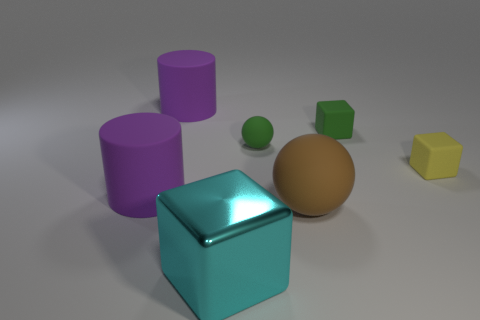There is a cyan metal object that is the same shape as the yellow object; what size is it?
Your answer should be compact. Large. Is the number of spheres that are left of the cyan thing the same as the number of small green balls behind the brown sphere?
Provide a short and direct response. No. What number of other things are the same material as the green block?
Your answer should be compact. 5. Is the number of yellow matte blocks that are left of the green rubber sphere the same as the number of blue matte spheres?
Provide a short and direct response. Yes. Does the brown object have the same size as the matte cube that is on the left side of the yellow cube?
Your response must be concise. No. There is a big rubber thing that is on the right side of the cyan thing; what is its shape?
Make the answer very short. Sphere. Are any brown metal things visible?
Make the answer very short. No. There is a cyan shiny thing that is in front of the brown thing; is its size the same as the rubber ball that is to the left of the brown sphere?
Offer a very short reply. No. What is the cube that is both left of the tiny yellow rubber thing and behind the big cyan cube made of?
Ensure brevity in your answer.  Rubber. How many matte cylinders are in front of the tiny green block?
Your answer should be very brief. 1. 